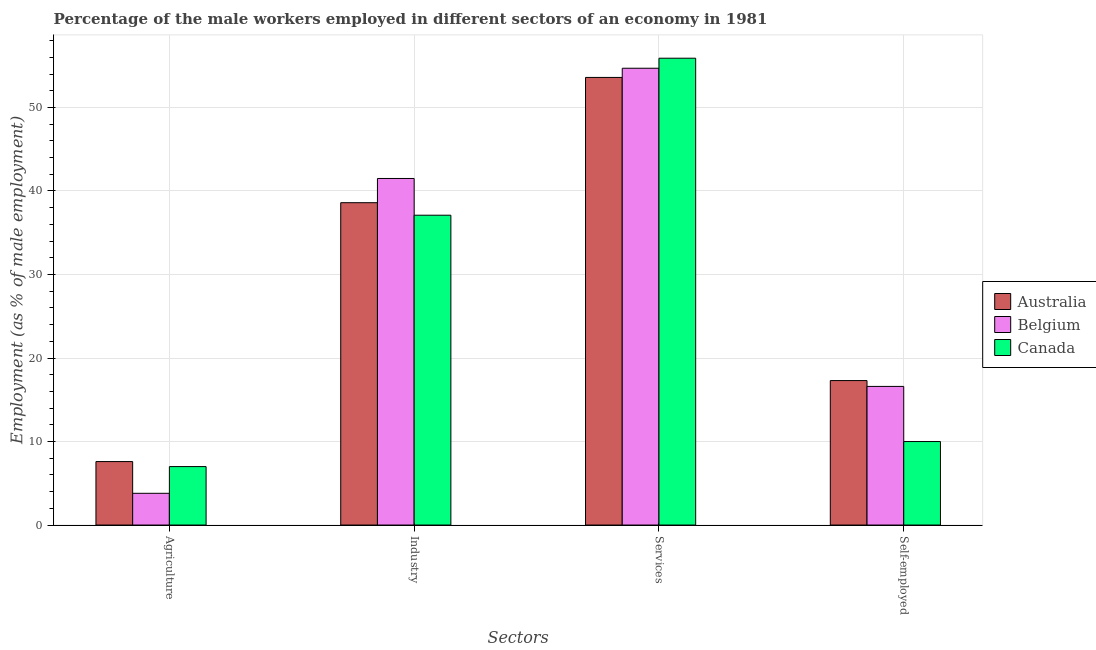How many groups of bars are there?
Offer a terse response. 4. Are the number of bars per tick equal to the number of legend labels?
Keep it short and to the point. Yes. Are the number of bars on each tick of the X-axis equal?
Your answer should be compact. Yes. How many bars are there on the 1st tick from the right?
Your response must be concise. 3. What is the label of the 3rd group of bars from the left?
Your response must be concise. Services. What is the percentage of male workers in industry in Australia?
Give a very brief answer. 38.6. Across all countries, what is the maximum percentage of male workers in services?
Make the answer very short. 55.9. Across all countries, what is the minimum percentage of male workers in agriculture?
Ensure brevity in your answer.  3.8. In which country was the percentage of male workers in agriculture minimum?
Offer a very short reply. Belgium. What is the total percentage of male workers in services in the graph?
Keep it short and to the point. 164.2. What is the difference between the percentage of male workers in agriculture in Australia and that in Canada?
Provide a short and direct response. 0.6. What is the difference between the percentage of male workers in services in Belgium and the percentage of self employed male workers in Australia?
Your response must be concise. 37.4. What is the average percentage of male workers in agriculture per country?
Offer a very short reply. 6.13. What is the difference between the percentage of male workers in agriculture and percentage of male workers in services in Canada?
Make the answer very short. -48.9. What is the ratio of the percentage of self employed male workers in Australia to that in Belgium?
Make the answer very short. 1.04. Is the difference between the percentage of self employed male workers in Australia and Belgium greater than the difference between the percentage of male workers in agriculture in Australia and Belgium?
Offer a terse response. No. What is the difference between the highest and the second highest percentage of male workers in services?
Ensure brevity in your answer.  1.2. What is the difference between the highest and the lowest percentage of male workers in services?
Keep it short and to the point. 2.3. In how many countries, is the percentage of male workers in agriculture greater than the average percentage of male workers in agriculture taken over all countries?
Ensure brevity in your answer.  2. Is the sum of the percentage of male workers in industry in Canada and Australia greater than the maximum percentage of self employed male workers across all countries?
Provide a succinct answer. Yes. What does the 3rd bar from the left in Agriculture represents?
Keep it short and to the point. Canada. How many bars are there?
Offer a terse response. 12. What is the difference between two consecutive major ticks on the Y-axis?
Offer a very short reply. 10. Are the values on the major ticks of Y-axis written in scientific E-notation?
Provide a succinct answer. No. Does the graph contain any zero values?
Provide a succinct answer. No. Where does the legend appear in the graph?
Provide a short and direct response. Center right. How many legend labels are there?
Keep it short and to the point. 3. What is the title of the graph?
Your answer should be compact. Percentage of the male workers employed in different sectors of an economy in 1981. Does "Upper middle income" appear as one of the legend labels in the graph?
Keep it short and to the point. No. What is the label or title of the X-axis?
Your answer should be very brief. Sectors. What is the label or title of the Y-axis?
Your answer should be very brief. Employment (as % of male employment). What is the Employment (as % of male employment) of Australia in Agriculture?
Ensure brevity in your answer.  7.6. What is the Employment (as % of male employment) in Belgium in Agriculture?
Provide a short and direct response. 3.8. What is the Employment (as % of male employment) in Australia in Industry?
Keep it short and to the point. 38.6. What is the Employment (as % of male employment) of Belgium in Industry?
Your answer should be very brief. 41.5. What is the Employment (as % of male employment) of Canada in Industry?
Provide a succinct answer. 37.1. What is the Employment (as % of male employment) of Australia in Services?
Offer a terse response. 53.6. What is the Employment (as % of male employment) in Belgium in Services?
Make the answer very short. 54.7. What is the Employment (as % of male employment) in Canada in Services?
Offer a terse response. 55.9. What is the Employment (as % of male employment) in Australia in Self-employed?
Provide a short and direct response. 17.3. What is the Employment (as % of male employment) in Belgium in Self-employed?
Provide a short and direct response. 16.6. Across all Sectors, what is the maximum Employment (as % of male employment) of Australia?
Give a very brief answer. 53.6. Across all Sectors, what is the maximum Employment (as % of male employment) of Belgium?
Make the answer very short. 54.7. Across all Sectors, what is the maximum Employment (as % of male employment) in Canada?
Make the answer very short. 55.9. Across all Sectors, what is the minimum Employment (as % of male employment) in Australia?
Give a very brief answer. 7.6. Across all Sectors, what is the minimum Employment (as % of male employment) of Belgium?
Your answer should be very brief. 3.8. What is the total Employment (as % of male employment) in Australia in the graph?
Your answer should be very brief. 117.1. What is the total Employment (as % of male employment) in Belgium in the graph?
Ensure brevity in your answer.  116.6. What is the total Employment (as % of male employment) in Canada in the graph?
Provide a short and direct response. 110. What is the difference between the Employment (as % of male employment) of Australia in Agriculture and that in Industry?
Your answer should be compact. -31. What is the difference between the Employment (as % of male employment) of Belgium in Agriculture and that in Industry?
Make the answer very short. -37.7. What is the difference between the Employment (as % of male employment) of Canada in Agriculture and that in Industry?
Your answer should be compact. -30.1. What is the difference between the Employment (as % of male employment) of Australia in Agriculture and that in Services?
Keep it short and to the point. -46. What is the difference between the Employment (as % of male employment) in Belgium in Agriculture and that in Services?
Keep it short and to the point. -50.9. What is the difference between the Employment (as % of male employment) of Canada in Agriculture and that in Services?
Provide a short and direct response. -48.9. What is the difference between the Employment (as % of male employment) of Canada in Agriculture and that in Self-employed?
Your answer should be very brief. -3. What is the difference between the Employment (as % of male employment) in Australia in Industry and that in Services?
Offer a very short reply. -15. What is the difference between the Employment (as % of male employment) in Canada in Industry and that in Services?
Offer a terse response. -18.8. What is the difference between the Employment (as % of male employment) of Australia in Industry and that in Self-employed?
Offer a terse response. 21.3. What is the difference between the Employment (as % of male employment) of Belgium in Industry and that in Self-employed?
Keep it short and to the point. 24.9. What is the difference between the Employment (as % of male employment) in Canada in Industry and that in Self-employed?
Provide a succinct answer. 27.1. What is the difference between the Employment (as % of male employment) in Australia in Services and that in Self-employed?
Make the answer very short. 36.3. What is the difference between the Employment (as % of male employment) of Belgium in Services and that in Self-employed?
Your response must be concise. 38.1. What is the difference between the Employment (as % of male employment) of Canada in Services and that in Self-employed?
Keep it short and to the point. 45.9. What is the difference between the Employment (as % of male employment) in Australia in Agriculture and the Employment (as % of male employment) in Belgium in Industry?
Offer a terse response. -33.9. What is the difference between the Employment (as % of male employment) of Australia in Agriculture and the Employment (as % of male employment) of Canada in Industry?
Keep it short and to the point. -29.5. What is the difference between the Employment (as % of male employment) of Belgium in Agriculture and the Employment (as % of male employment) of Canada in Industry?
Your response must be concise. -33.3. What is the difference between the Employment (as % of male employment) of Australia in Agriculture and the Employment (as % of male employment) of Belgium in Services?
Provide a short and direct response. -47.1. What is the difference between the Employment (as % of male employment) of Australia in Agriculture and the Employment (as % of male employment) of Canada in Services?
Provide a short and direct response. -48.3. What is the difference between the Employment (as % of male employment) in Belgium in Agriculture and the Employment (as % of male employment) in Canada in Services?
Your response must be concise. -52.1. What is the difference between the Employment (as % of male employment) in Australia in Agriculture and the Employment (as % of male employment) in Belgium in Self-employed?
Keep it short and to the point. -9. What is the difference between the Employment (as % of male employment) of Australia in Industry and the Employment (as % of male employment) of Belgium in Services?
Provide a succinct answer. -16.1. What is the difference between the Employment (as % of male employment) in Australia in Industry and the Employment (as % of male employment) in Canada in Services?
Provide a short and direct response. -17.3. What is the difference between the Employment (as % of male employment) in Belgium in Industry and the Employment (as % of male employment) in Canada in Services?
Your answer should be compact. -14.4. What is the difference between the Employment (as % of male employment) of Australia in Industry and the Employment (as % of male employment) of Canada in Self-employed?
Offer a terse response. 28.6. What is the difference between the Employment (as % of male employment) of Belgium in Industry and the Employment (as % of male employment) of Canada in Self-employed?
Give a very brief answer. 31.5. What is the difference between the Employment (as % of male employment) of Australia in Services and the Employment (as % of male employment) of Belgium in Self-employed?
Ensure brevity in your answer.  37. What is the difference between the Employment (as % of male employment) in Australia in Services and the Employment (as % of male employment) in Canada in Self-employed?
Offer a very short reply. 43.6. What is the difference between the Employment (as % of male employment) of Belgium in Services and the Employment (as % of male employment) of Canada in Self-employed?
Make the answer very short. 44.7. What is the average Employment (as % of male employment) of Australia per Sectors?
Provide a short and direct response. 29.27. What is the average Employment (as % of male employment) of Belgium per Sectors?
Ensure brevity in your answer.  29.15. What is the average Employment (as % of male employment) in Canada per Sectors?
Keep it short and to the point. 27.5. What is the difference between the Employment (as % of male employment) of Australia and Employment (as % of male employment) of Canada in Agriculture?
Your response must be concise. 0.6. What is the difference between the Employment (as % of male employment) of Australia and Employment (as % of male employment) of Canada in Industry?
Make the answer very short. 1.5. What is the difference between the Employment (as % of male employment) in Australia and Employment (as % of male employment) in Canada in Services?
Give a very brief answer. -2.3. What is the difference between the Employment (as % of male employment) of Belgium and Employment (as % of male employment) of Canada in Services?
Provide a succinct answer. -1.2. What is the ratio of the Employment (as % of male employment) of Australia in Agriculture to that in Industry?
Offer a very short reply. 0.2. What is the ratio of the Employment (as % of male employment) in Belgium in Agriculture to that in Industry?
Give a very brief answer. 0.09. What is the ratio of the Employment (as % of male employment) in Canada in Agriculture to that in Industry?
Offer a terse response. 0.19. What is the ratio of the Employment (as % of male employment) in Australia in Agriculture to that in Services?
Ensure brevity in your answer.  0.14. What is the ratio of the Employment (as % of male employment) in Belgium in Agriculture to that in Services?
Offer a terse response. 0.07. What is the ratio of the Employment (as % of male employment) of Canada in Agriculture to that in Services?
Make the answer very short. 0.13. What is the ratio of the Employment (as % of male employment) in Australia in Agriculture to that in Self-employed?
Ensure brevity in your answer.  0.44. What is the ratio of the Employment (as % of male employment) of Belgium in Agriculture to that in Self-employed?
Offer a very short reply. 0.23. What is the ratio of the Employment (as % of male employment) of Canada in Agriculture to that in Self-employed?
Offer a terse response. 0.7. What is the ratio of the Employment (as % of male employment) in Australia in Industry to that in Services?
Provide a succinct answer. 0.72. What is the ratio of the Employment (as % of male employment) of Belgium in Industry to that in Services?
Keep it short and to the point. 0.76. What is the ratio of the Employment (as % of male employment) in Canada in Industry to that in Services?
Provide a succinct answer. 0.66. What is the ratio of the Employment (as % of male employment) in Australia in Industry to that in Self-employed?
Your answer should be very brief. 2.23. What is the ratio of the Employment (as % of male employment) in Belgium in Industry to that in Self-employed?
Give a very brief answer. 2.5. What is the ratio of the Employment (as % of male employment) of Canada in Industry to that in Self-employed?
Your answer should be compact. 3.71. What is the ratio of the Employment (as % of male employment) in Australia in Services to that in Self-employed?
Make the answer very short. 3.1. What is the ratio of the Employment (as % of male employment) of Belgium in Services to that in Self-employed?
Make the answer very short. 3.3. What is the ratio of the Employment (as % of male employment) of Canada in Services to that in Self-employed?
Give a very brief answer. 5.59. What is the difference between the highest and the second highest Employment (as % of male employment) in Belgium?
Make the answer very short. 13.2. What is the difference between the highest and the second highest Employment (as % of male employment) in Canada?
Provide a succinct answer. 18.8. What is the difference between the highest and the lowest Employment (as % of male employment) of Australia?
Your answer should be compact. 46. What is the difference between the highest and the lowest Employment (as % of male employment) in Belgium?
Offer a terse response. 50.9. What is the difference between the highest and the lowest Employment (as % of male employment) in Canada?
Provide a short and direct response. 48.9. 